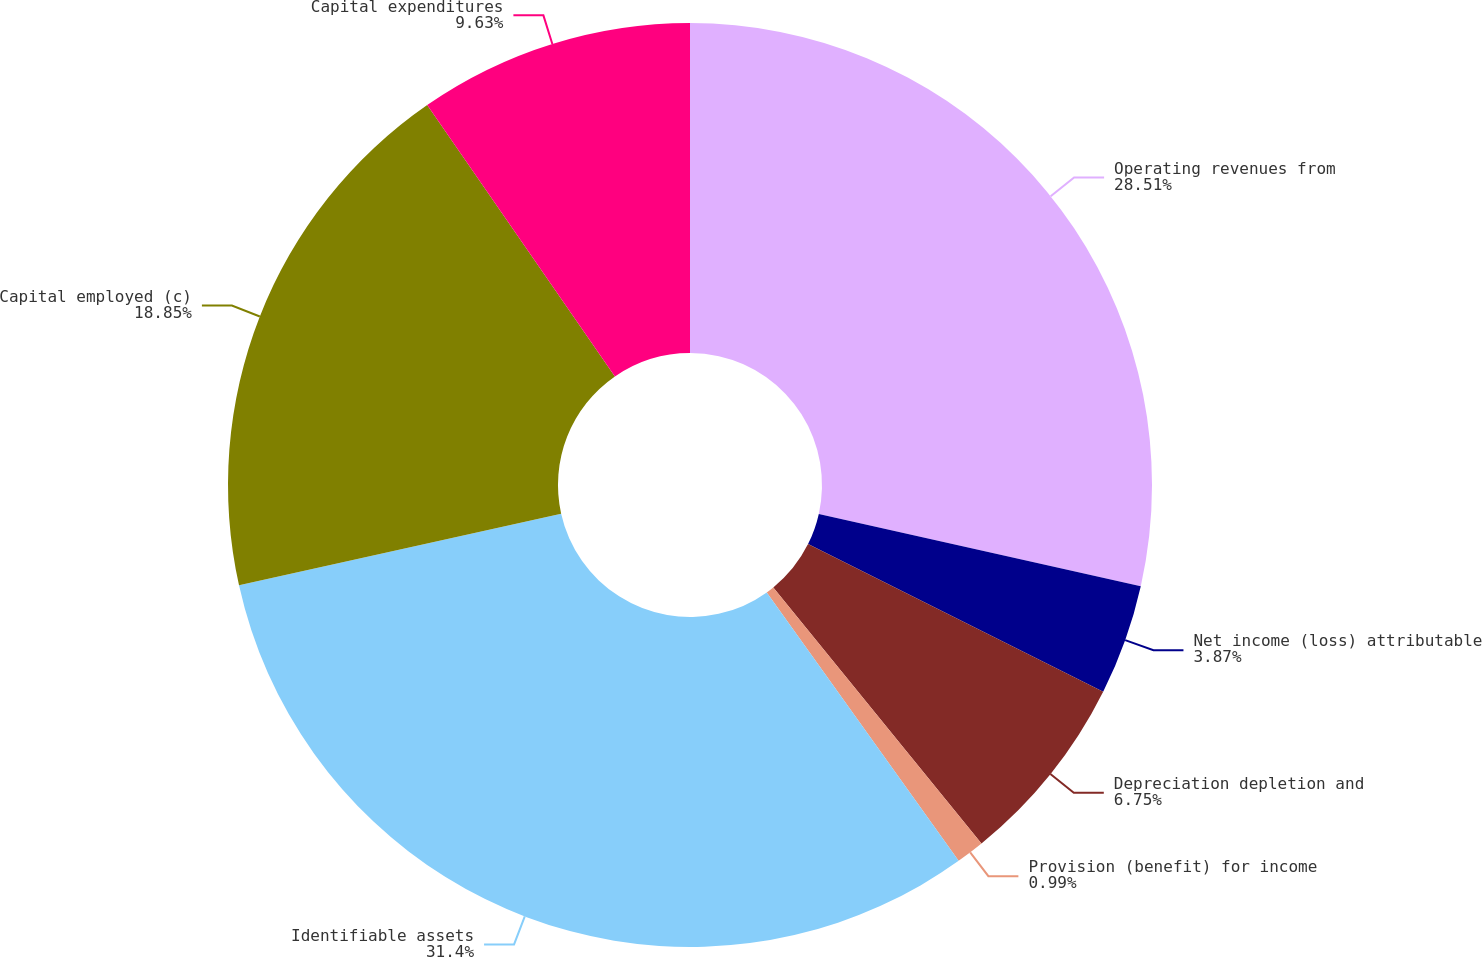Convert chart to OTSL. <chart><loc_0><loc_0><loc_500><loc_500><pie_chart><fcel>Operating revenues from<fcel>Net income (loss) attributable<fcel>Depreciation depletion and<fcel>Provision (benefit) for income<fcel>Identifiable assets<fcel>Capital employed (c)<fcel>Capital expenditures<nl><fcel>28.51%<fcel>3.87%<fcel>6.75%<fcel>0.99%<fcel>31.39%<fcel>18.85%<fcel>9.63%<nl></chart> 